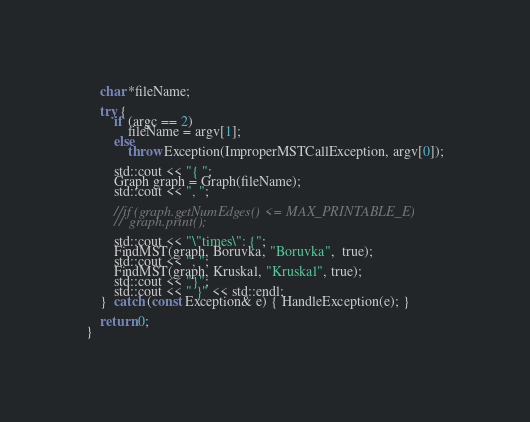<code> <loc_0><loc_0><loc_500><loc_500><_C++_>
	char *fileName;

	try {
		if (argc == 2)
			fileName = argv[1];
		else
			throw Exception(ImproperMSTCallException, argv[0]);

		std::cout << "{ ";
		Graph graph = Graph(fileName);
		std::cout << ", ";

		//if (graph.getNumEdges() <= MAX_PRINTABLE_E)
		//	graph.print();

		std::cout << "\"times\": {";
		FindMST(graph, Boruvka, "Boruvka",  true);
		std::cout << ", ";
		FindMST(graph, Kruskal, "Kruskal", true);
		std::cout << "}";
		std::cout << " }" << std::endl;
	}  catch (const Exception& e) { HandleException(e); }

	return 0;
}
</code> 